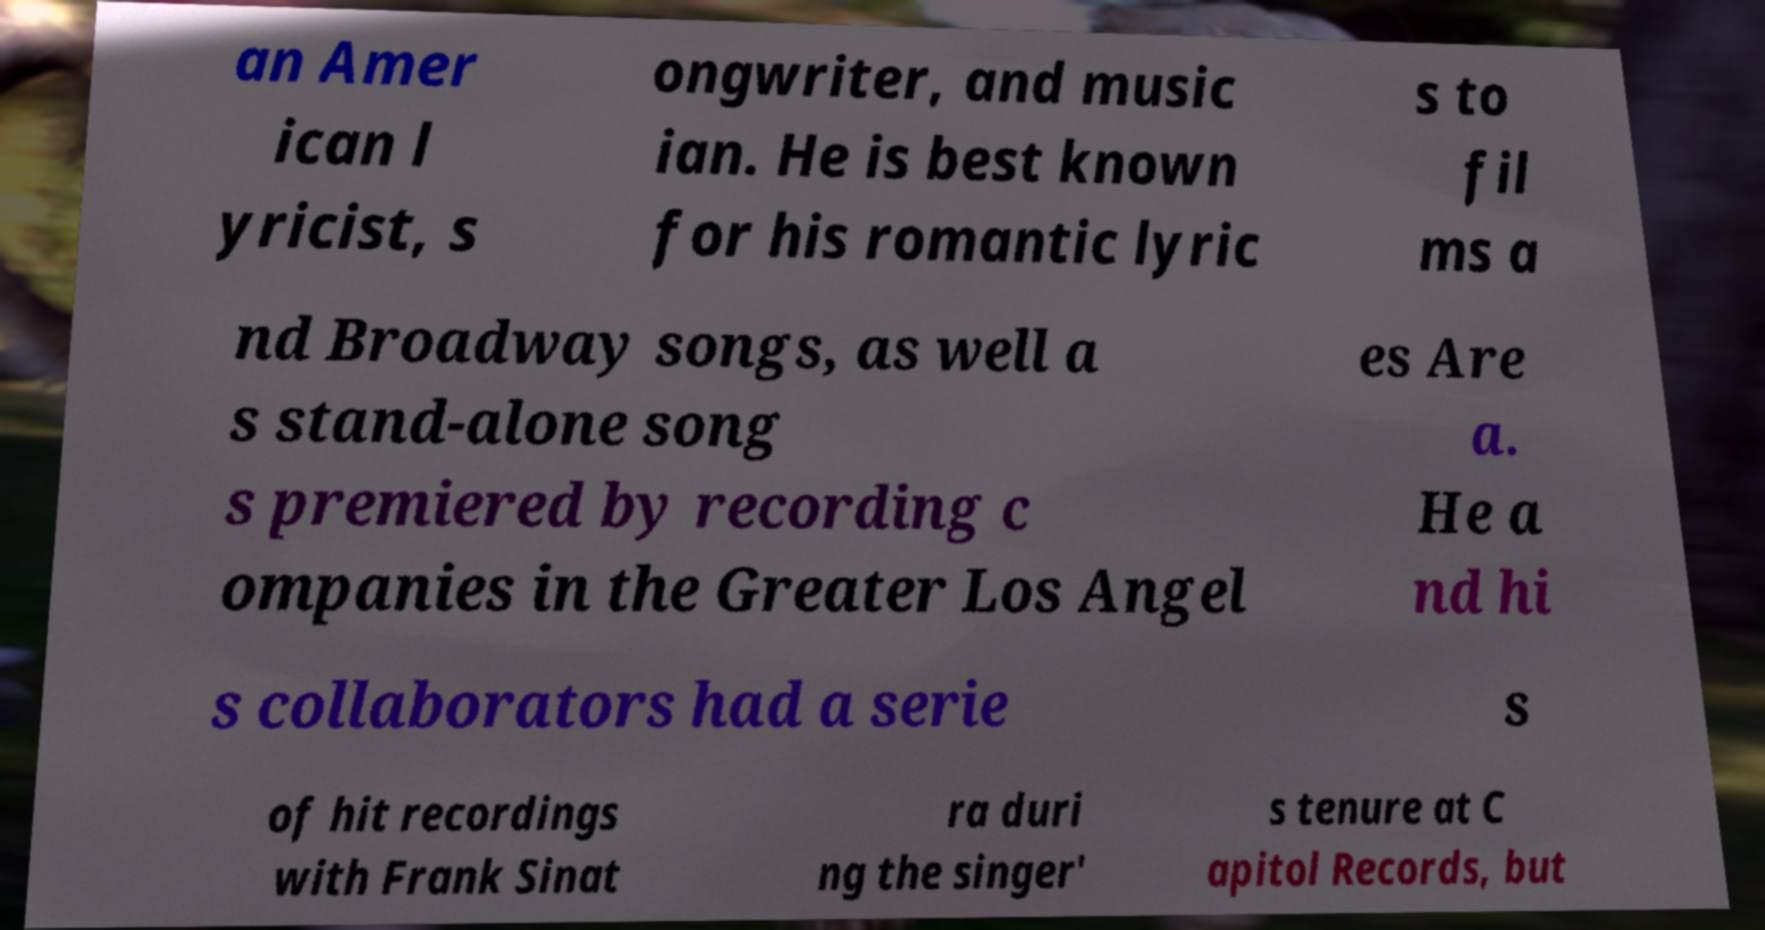For documentation purposes, I need the text within this image transcribed. Could you provide that? an Amer ican l yricist, s ongwriter, and music ian. He is best known for his romantic lyric s to fil ms a nd Broadway songs, as well a s stand-alone song s premiered by recording c ompanies in the Greater Los Angel es Are a. He a nd hi s collaborators had a serie s of hit recordings with Frank Sinat ra duri ng the singer' s tenure at C apitol Records, but 